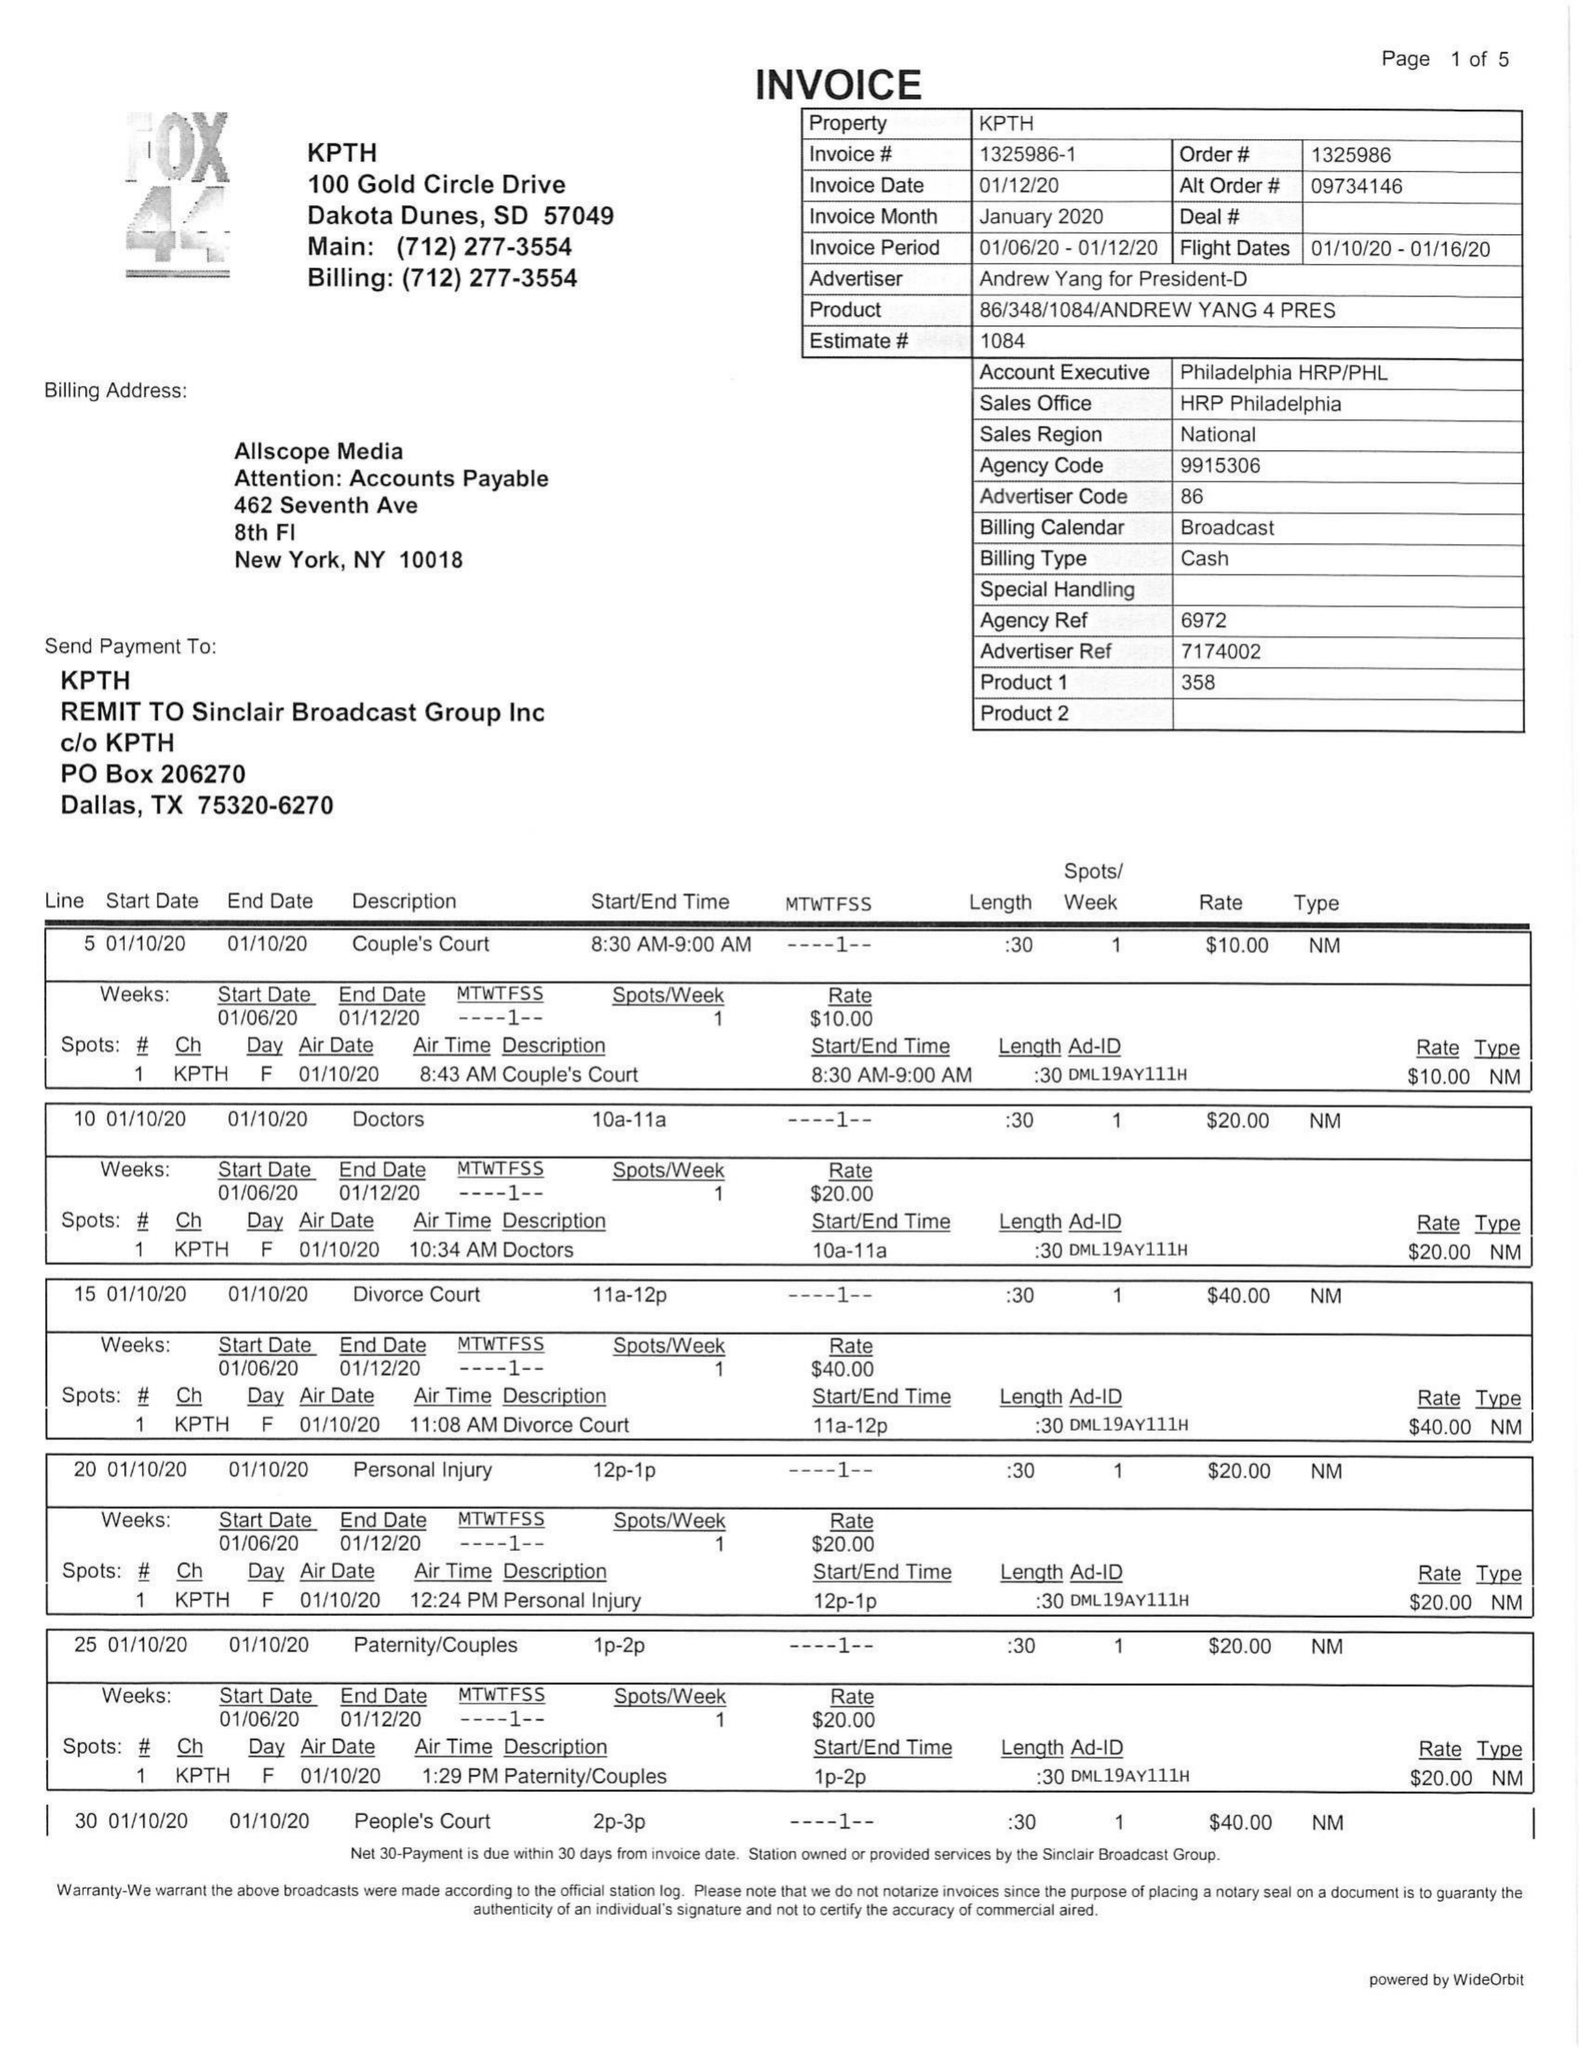What is the value for the flight_from?
Answer the question using a single word or phrase. 01/10/20 